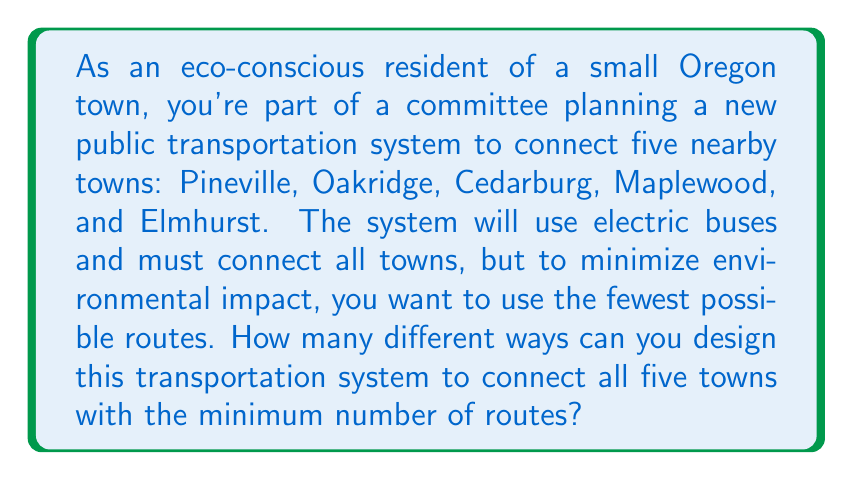Could you help me with this problem? Let's approach this step-by-step:

1) First, we need to understand what the minimum number of routes would be. To connect 5 towns with the fewest possible routes, we need 4 routes. This forms a tree structure where each town is connected to at least one other town.

2) In graph theory, this is known as a spanning tree. The number of spanning trees in a complete graph is given by Cayley's formula:

   $$n^{n-2}$$

   where $n$ is the number of vertices (in our case, towns).

3) In our problem, we have 5 towns. So, $n = 5$.

4) Plugging this into Cayley's formula:

   $$5^{5-2} = 5^3 = 125$$

5) Therefore, there are 125 different ways to connect these 5 towns using the minimum number of routes (4 routes).

This means that the committee has 125 different options to consider when designing the most efficient and eco-friendly public transportation system.
Answer: $125$ different ways 